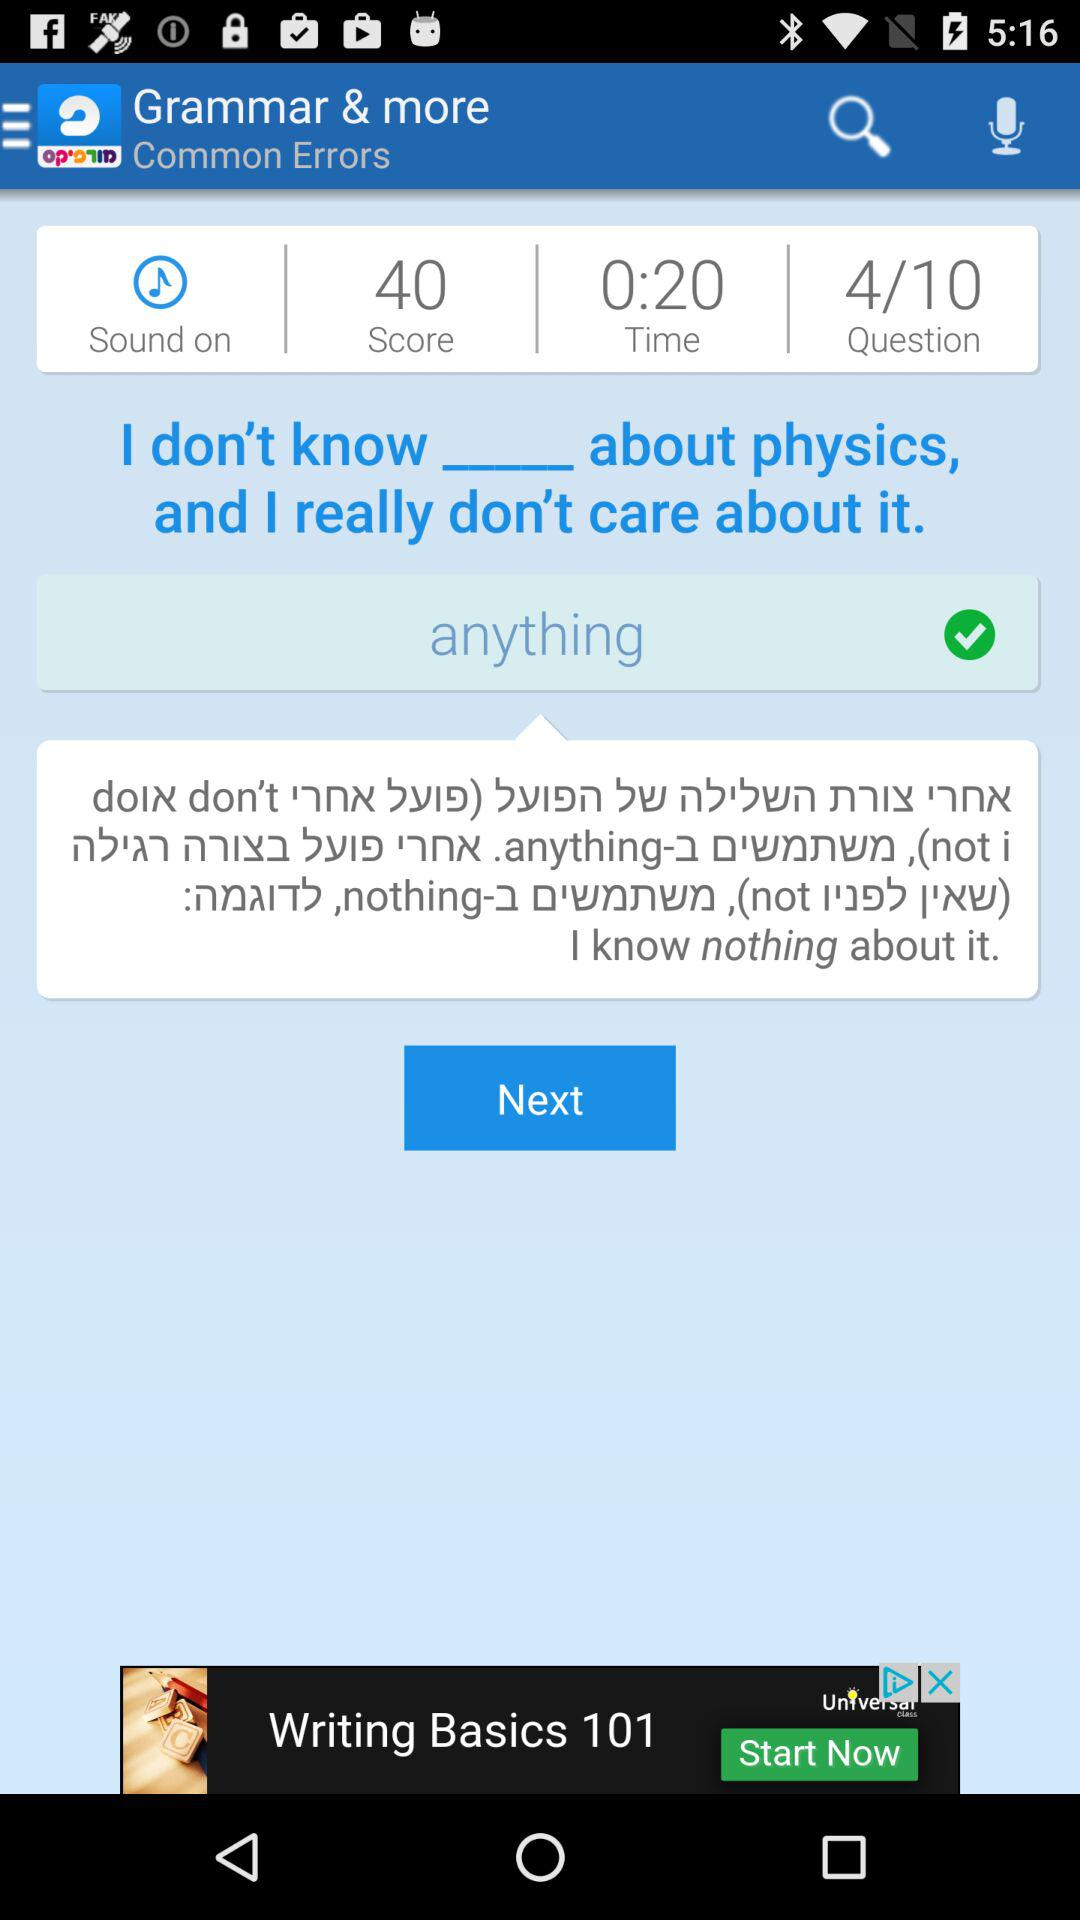What's the time? The time is 20 seconds. 